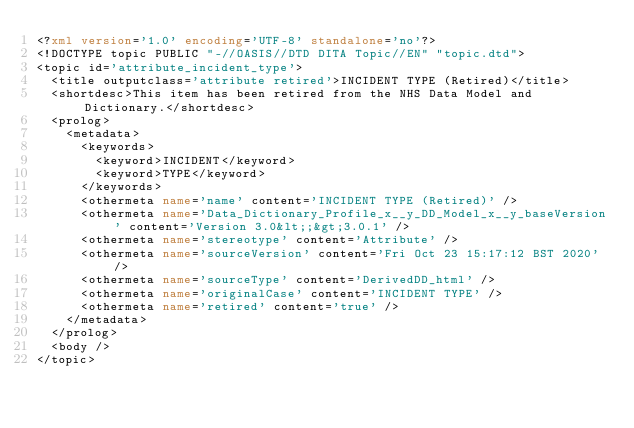Convert code to text. <code><loc_0><loc_0><loc_500><loc_500><_XML_><?xml version='1.0' encoding='UTF-8' standalone='no'?>
<!DOCTYPE topic PUBLIC "-//OASIS//DTD DITA Topic//EN" "topic.dtd">
<topic id='attribute_incident_type'>
  <title outputclass='attribute retired'>INCIDENT TYPE (Retired)</title>
  <shortdesc>This item has been retired from the NHS Data Model and Dictionary.</shortdesc>
  <prolog>
    <metadata>
      <keywords>
        <keyword>INCIDENT</keyword>
        <keyword>TYPE</keyword>
      </keywords>
      <othermeta name='name' content='INCIDENT TYPE (Retired)' />
      <othermeta name='Data_Dictionary_Profile_x__y_DD_Model_x__y_baseVersion' content='Version 3.0&lt;;&gt;3.0.1' />
      <othermeta name='stereotype' content='Attribute' />
      <othermeta name='sourceVersion' content='Fri Oct 23 15:17:12 BST 2020' />
      <othermeta name='sourceType' content='DerivedDD_html' />
      <othermeta name='originalCase' content='INCIDENT TYPE' />
      <othermeta name='retired' content='true' />
    </metadata>
  </prolog>
  <body />
</topic></code> 